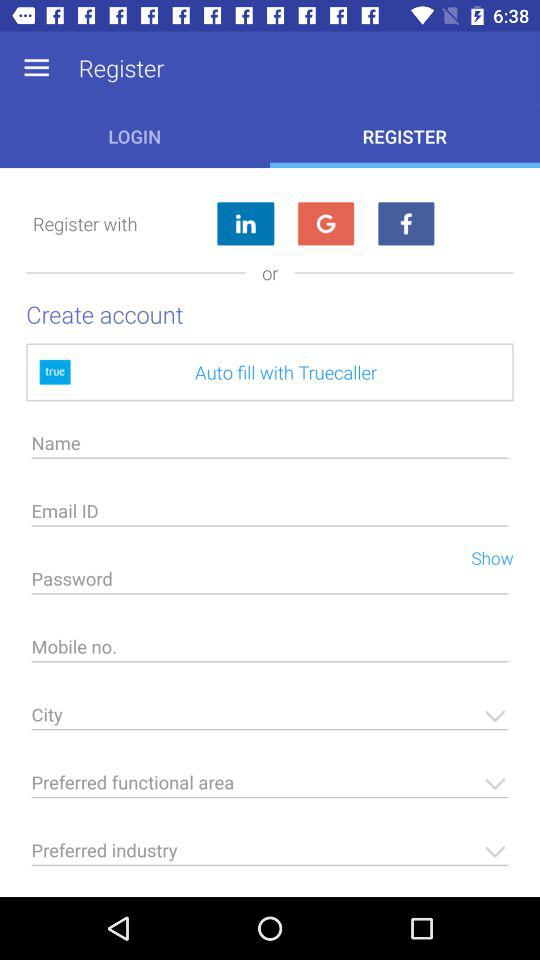How many characters are required to create a password?
When the provided information is insufficient, respond with <no answer>. <no answer> 